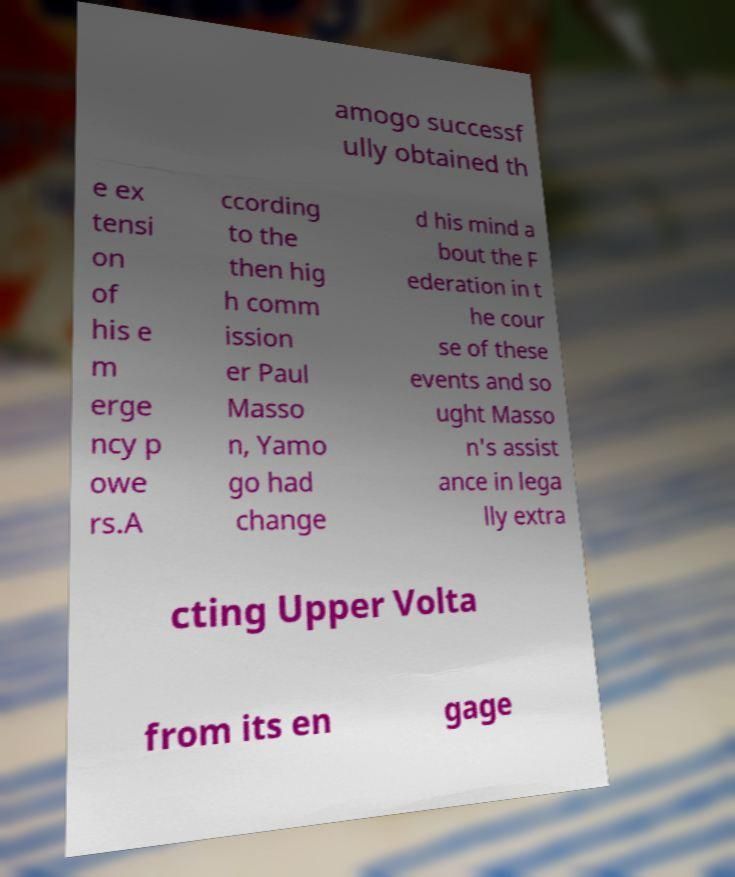Can you read and provide the text displayed in the image?This photo seems to have some interesting text. Can you extract and type it out for me? amogo successf ully obtained th e ex tensi on of his e m erge ncy p owe rs.A ccording to the then hig h comm ission er Paul Masso n, Yamo go had change d his mind a bout the F ederation in t he cour se of these events and so ught Masso n's assist ance in lega lly extra cting Upper Volta from its en gage 